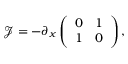<formula> <loc_0><loc_0><loc_500><loc_500>\ m a t h s c r { J } = - \partial _ { x } \left ( \begin{array} { l l } { 0 } & { 1 } \\ { 1 } & { 0 } \end{array} \right ) ,</formula> 